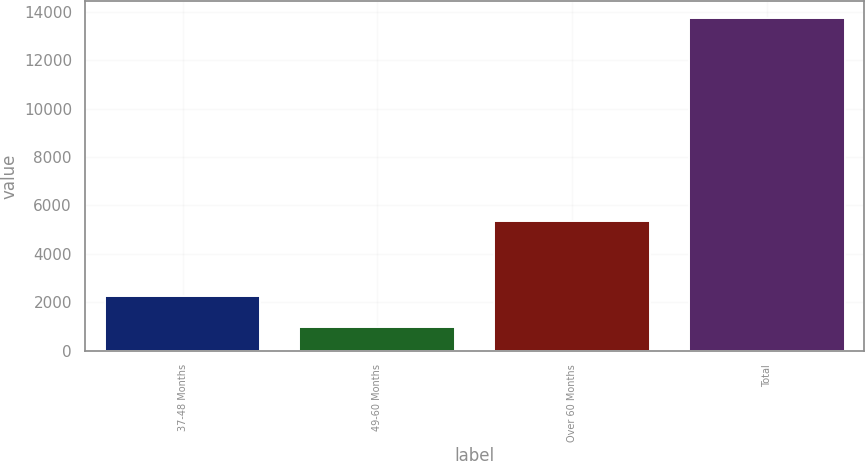Convert chart. <chart><loc_0><loc_0><loc_500><loc_500><bar_chart><fcel>37-48 Months<fcel>49-60 Months<fcel>Over 60 Months<fcel>Total<nl><fcel>2266<fcel>992<fcel>5337<fcel>13732<nl></chart> 